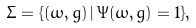<formula> <loc_0><loc_0><loc_500><loc_500>\Sigma = \{ ( \omega , g ) \, | \, \Psi ( \omega , g ) = 1 \} ,</formula> 